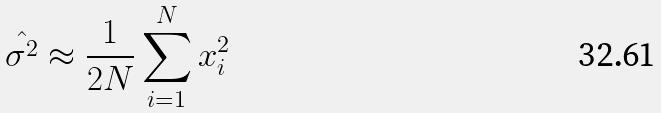Convert formula to latex. <formula><loc_0><loc_0><loc_500><loc_500>\hat { \sigma ^ { 2 } } \approx \frac { 1 } { 2 N } \sum _ { i = 1 } ^ { N } x _ { i } ^ { 2 }</formula> 